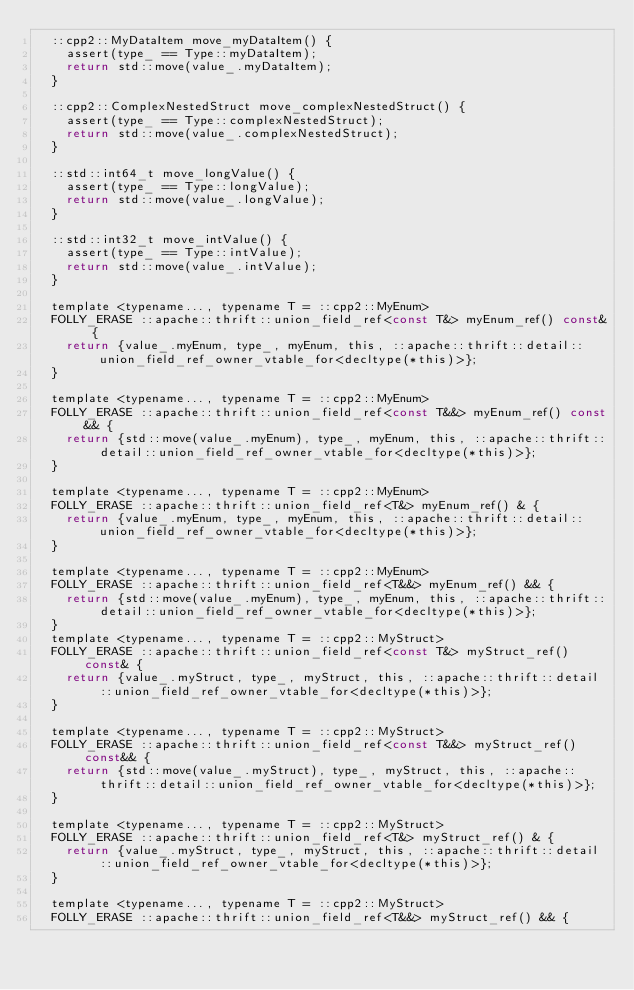Convert code to text. <code><loc_0><loc_0><loc_500><loc_500><_C_>  ::cpp2::MyDataItem move_myDataItem() {
    assert(type_ == Type::myDataItem);
    return std::move(value_.myDataItem);
  }

  ::cpp2::ComplexNestedStruct move_complexNestedStruct() {
    assert(type_ == Type::complexNestedStruct);
    return std::move(value_.complexNestedStruct);
  }

  ::std::int64_t move_longValue() {
    assert(type_ == Type::longValue);
    return std::move(value_.longValue);
  }

  ::std::int32_t move_intValue() {
    assert(type_ == Type::intValue);
    return std::move(value_.intValue);
  }

  template <typename..., typename T = ::cpp2::MyEnum>
  FOLLY_ERASE ::apache::thrift::union_field_ref<const T&> myEnum_ref() const& {
    return {value_.myEnum, type_, myEnum, this, ::apache::thrift::detail::union_field_ref_owner_vtable_for<decltype(*this)>};
  }

  template <typename..., typename T = ::cpp2::MyEnum>
  FOLLY_ERASE ::apache::thrift::union_field_ref<const T&&> myEnum_ref() const&& {
    return {std::move(value_.myEnum), type_, myEnum, this, ::apache::thrift::detail::union_field_ref_owner_vtable_for<decltype(*this)>};
  }

  template <typename..., typename T = ::cpp2::MyEnum>
  FOLLY_ERASE ::apache::thrift::union_field_ref<T&> myEnum_ref() & {
    return {value_.myEnum, type_, myEnum, this, ::apache::thrift::detail::union_field_ref_owner_vtable_for<decltype(*this)>};
  }

  template <typename..., typename T = ::cpp2::MyEnum>
  FOLLY_ERASE ::apache::thrift::union_field_ref<T&&> myEnum_ref() && {
    return {std::move(value_.myEnum), type_, myEnum, this, ::apache::thrift::detail::union_field_ref_owner_vtable_for<decltype(*this)>};
  }
  template <typename..., typename T = ::cpp2::MyStruct>
  FOLLY_ERASE ::apache::thrift::union_field_ref<const T&> myStruct_ref() const& {
    return {value_.myStruct, type_, myStruct, this, ::apache::thrift::detail::union_field_ref_owner_vtable_for<decltype(*this)>};
  }

  template <typename..., typename T = ::cpp2::MyStruct>
  FOLLY_ERASE ::apache::thrift::union_field_ref<const T&&> myStruct_ref() const&& {
    return {std::move(value_.myStruct), type_, myStruct, this, ::apache::thrift::detail::union_field_ref_owner_vtable_for<decltype(*this)>};
  }

  template <typename..., typename T = ::cpp2::MyStruct>
  FOLLY_ERASE ::apache::thrift::union_field_ref<T&> myStruct_ref() & {
    return {value_.myStruct, type_, myStruct, this, ::apache::thrift::detail::union_field_ref_owner_vtable_for<decltype(*this)>};
  }

  template <typename..., typename T = ::cpp2::MyStruct>
  FOLLY_ERASE ::apache::thrift::union_field_ref<T&&> myStruct_ref() && {</code> 